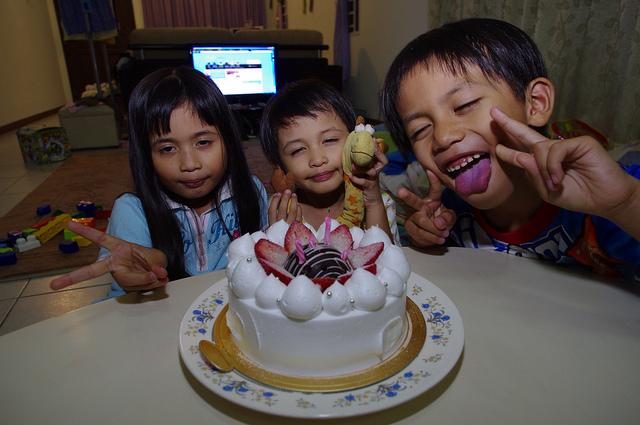What color are the dolls eyes?
Quick response, please. White. What is the child's gender?
Short answer required. Male. Have these people just married?
Be succinct. No. What colors is the birthday cake?
Be succinct. White. What is round on table?
Short answer required. Cake. How many kids are there?
Answer briefly. 3. What is behind the girl?
Concise answer only. Tv. What fruit is on the cake?
Be succinct. Strawberry. What type of cake is it?
Short answer required. Birthday. What dessert are the children looking at?
Answer briefly. Cake. What age is being celebrated?
Be succinct. 4. Are there hands clasped?
Be succinct. No. What color is the flower on the plates?
Short answer required. Blue. How many tiers does the cake have?
Give a very brief answer. 1. What event is pictured?
Be succinct. Birthday. Is the boy smiling?
Write a very short answer. Yes. What are the colors of the cake?
Write a very short answer. White. Is it daytime?
Concise answer only. No. How many tiers are on the cake?
Be succinct. 1. How many people are wearing glasses?
Answer briefly. 0. Are there adults in the photo?
Be succinct. No. 